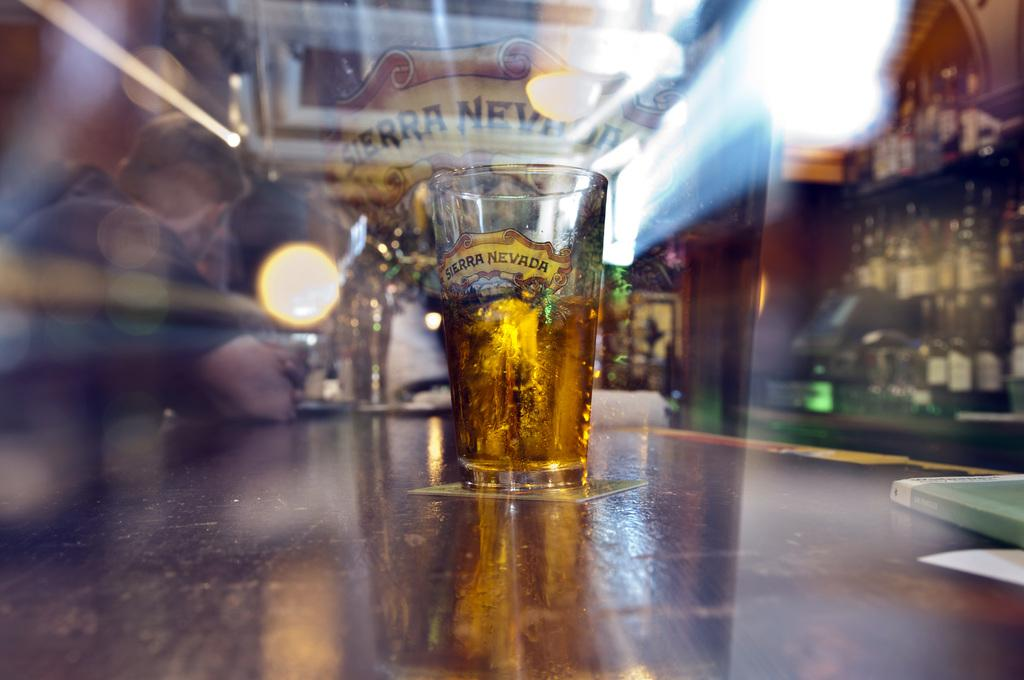<image>
Share a concise interpretation of the image provided. A half-full Sierra Nevada beer glass sits on a gleaming bar top. 